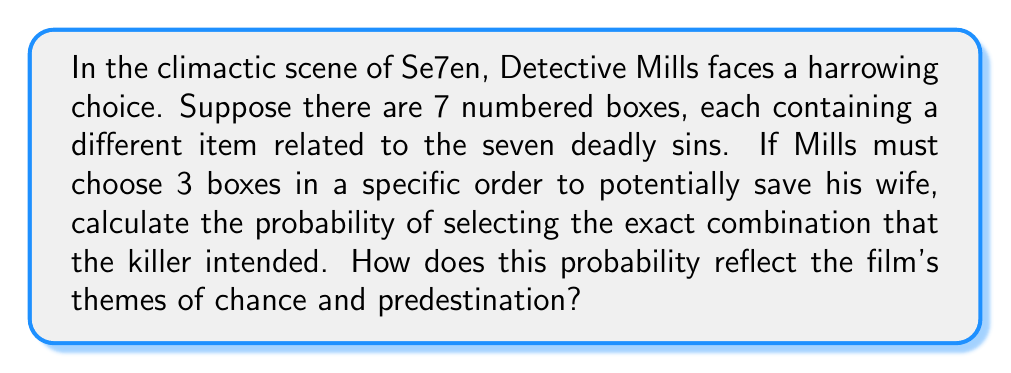What is the answer to this math problem? Let's approach this step-by-step, using the number 7 as a nod to the film's title:

1) First, we need to calculate the total number of possible combinations when selecting 3 boxes out of 7 in a specific order. This is a permutation problem.

2) The number of permutations is given by the formula:
   $$P(7,3) = \frac{7!}{(7-3)!} = \frac{7!}{4!}$$

3) Let's calculate this:
   $$\frac{7 \cdot 6 \cdot 5 \cdot 4!}{4!} = 7 \cdot 6 \cdot 5 = 210$$

4) There are 210 possible combinations.

5) The killer intended only one specific combination. Therefore, the probability of choosing this exact combination is:
   $$P(\text{correct combination}) = \frac{1}{210}$$

6) To express this as a percentage:
   $$\frac{1}{210} \cdot 100\% \approx 0.476\%$$

This extremely low probability reflects the film's themes of chance and predestination. The near-impossibility of guessing the correct combination mirrors the characters' struggle against a seemingly predetermined fate, much like the intricate plot of David Fincher's Se7en or the complex conspiracies in Utopia.
Answer: The probability of selecting the exact combination intended by the killer is $\frac{1}{210}$ or approximately $0.476\%$. 